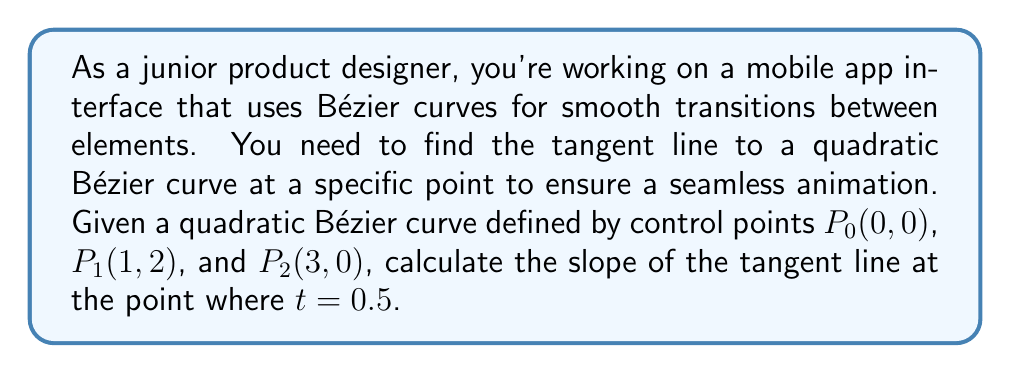Solve this math problem. Let's approach this step-by-step:

1) A quadratic Bézier curve is defined by the equation:
   $$B(t) = (1-t)^2P_0 + 2t(1-t)P_1 + t^2P_2$$
   where $0 \leq t \leq 1$

2) The derivative of this curve gives us the tangent vector:
   $$B'(t) = 2(1-t)(P_1-P_0) + 2t(P_2-P_1)$$

3) We're given:
   $P_0(0,0)$, $P_1(1,2)$, and $P_2(3,0)$

4) Substituting $t=0.5$ into the derivative equation:
   $$B'(0.5) = 2(0.5)(P_1-P_0) + 2(0.5)(P_2-P_1)$$
   $$= (P_1-P_0) + (P_2-P_1)$$

5) Calculate $P_1-P_0$:
   $$(1,2) - (0,0) = (1,2)$$

6) Calculate $P_2-P_1$:
   $$(3,0) - (1,2) = (2,-2)$$

7) Add these vectors:
   $$(1,2) + (2,-2) = (3,0)$$

8) The slope of the tangent line is the y-component divided by the x-component:
   $$\text{slope} = \frac{0}{3} = 0$$

Therefore, the slope of the tangent line at $t=0.5$ is 0, meaning it's a horizontal line.
Answer: 0 